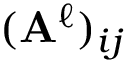Convert formula to latex. <formula><loc_0><loc_0><loc_500><loc_500>( A ^ { \ell } ) _ { i j }</formula> 